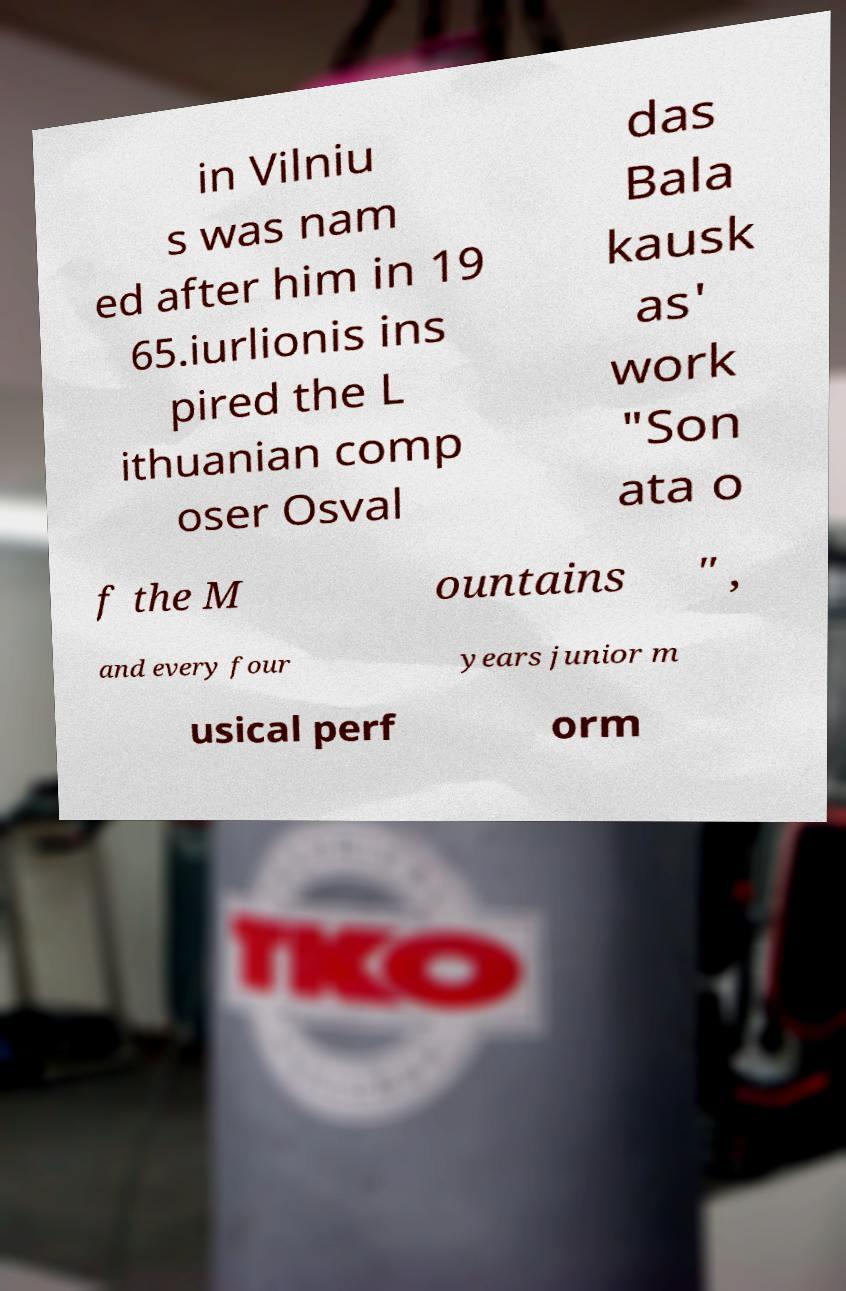Could you extract and type out the text from this image? in Vilniu s was nam ed after him in 19 65.iurlionis ins pired the L ithuanian comp oser Osval das Bala kausk as' work "Son ata o f the M ountains " , and every four years junior m usical perf orm 